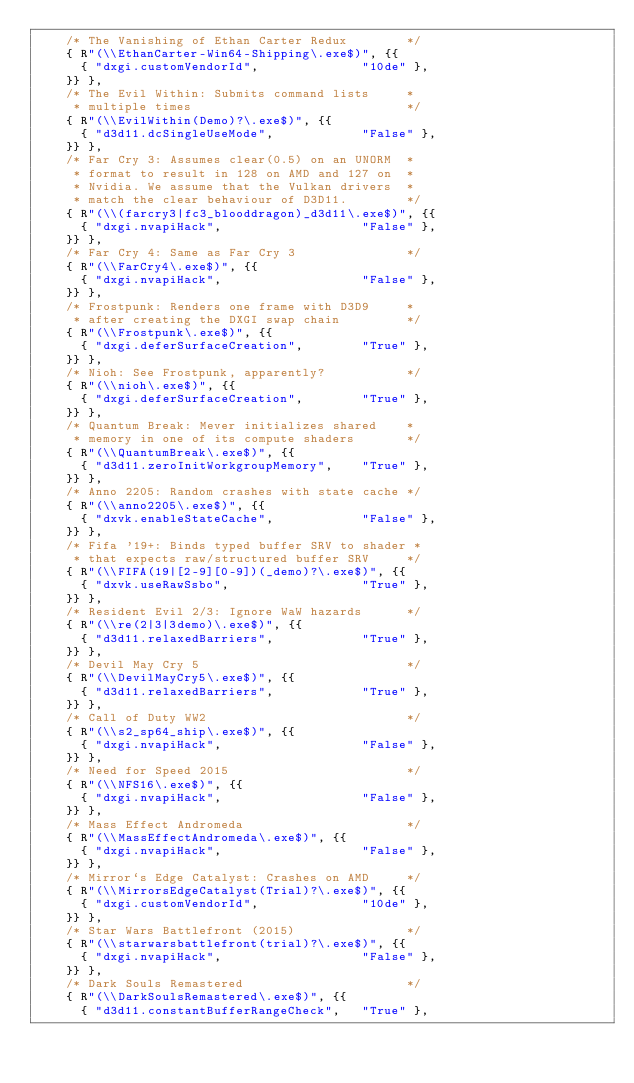<code> <loc_0><loc_0><loc_500><loc_500><_C++_>    /* The Vanishing of Ethan Carter Redux        */
    { R"(\\EthanCarter-Win64-Shipping\.exe$)", {{
      { "dxgi.customVendorId",              "10de" },
    }} },
    /* The Evil Within: Submits command lists     * 
     * multiple times                             */
    { R"(\\EvilWithin(Demo)?\.exe$)", {{
      { "d3d11.dcSingleUseMode",            "False" },
    }} },
    /* Far Cry 3: Assumes clear(0.5) on an UNORM  *
     * format to result in 128 on AMD and 127 on  *
     * Nvidia. We assume that the Vulkan drivers  *
     * match the clear behaviour of D3D11.        */
    { R"(\\(farcry3|fc3_blooddragon)_d3d11\.exe$)", {{
      { "dxgi.nvapiHack",                   "False" },
    }} },
    /* Far Cry 4: Same as Far Cry 3               */
    { R"(\\FarCry4\.exe$)", {{
      { "dxgi.nvapiHack",                   "False" },
    }} },
    /* Frostpunk: Renders one frame with D3D9     *
     * after creating the DXGI swap chain         */
    { R"(\\Frostpunk\.exe$)", {{
      { "dxgi.deferSurfaceCreation",        "True" },
    }} },
    /* Nioh: See Frostpunk, apparently?           */
    { R"(\\nioh\.exe$)", {{
      { "dxgi.deferSurfaceCreation",        "True" },
    }} },
    /* Quantum Break: Mever initializes shared    *
     * memory in one of its compute shaders       */
    { R"(\\QuantumBreak\.exe$)", {{
      { "d3d11.zeroInitWorkgroupMemory",    "True" },
    }} },
    /* Anno 2205: Random crashes with state cache */
    { R"(\\anno2205\.exe$)", {{
      { "dxvk.enableStateCache",            "False" },
    }} },
    /* Fifa '19+: Binds typed buffer SRV to shader *
     * that expects raw/structured buffer SRV     */
    { R"(\\FIFA(19|[2-9][0-9])(_demo)?\.exe$)", {{
      { "dxvk.useRawSsbo",                  "True" },
    }} },
    /* Resident Evil 2/3: Ignore WaW hazards      */
    { R"(\\re(2|3|3demo)\.exe$)", {{
      { "d3d11.relaxedBarriers",            "True" },
    }} },
    /* Devil May Cry 5                            */
    { R"(\\DevilMayCry5\.exe$)", {{
      { "d3d11.relaxedBarriers",            "True" },
    }} },
    /* Call of Duty WW2                           */
    { R"(\\s2_sp64_ship\.exe$)", {{
      { "dxgi.nvapiHack",                   "False" },
    }} },
    /* Need for Speed 2015                        */
    { R"(\\NFS16\.exe$)", {{
      { "dxgi.nvapiHack",                   "False" },
    }} },
    /* Mass Effect Andromeda                      */
    { R"(\\MassEffectAndromeda\.exe$)", {{
      { "dxgi.nvapiHack",                   "False" },
    }} },
    /* Mirror`s Edge Catalyst: Crashes on AMD     */
    { R"(\\MirrorsEdgeCatalyst(Trial)?\.exe$)", {{
      { "dxgi.customVendorId",              "10de" },
    }} },
    /* Star Wars Battlefront (2015)               */
    { R"(\\starwarsbattlefront(trial)?\.exe$)", {{
      { "dxgi.nvapiHack",                   "False" },
    }} },
    /* Dark Souls Remastered                      */
    { R"(\\DarkSoulsRemastered\.exe$)", {{
      { "d3d11.constantBufferRangeCheck",   "True" },</code> 